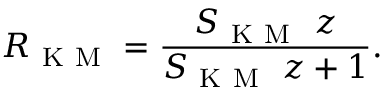Convert formula to latex. <formula><loc_0><loc_0><loc_500><loc_500>R _ { K M } = \frac { S _ { K M } \, z } { S _ { K M } \, z + 1 } .</formula> 